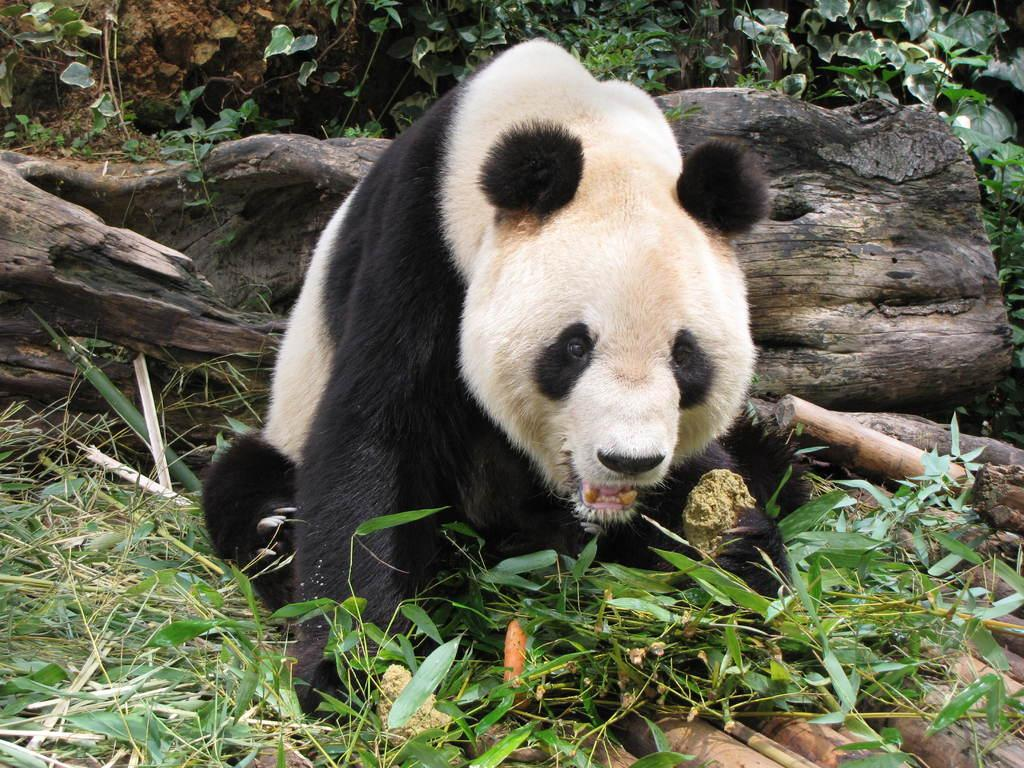What animal is featured in the picture? There is a panda in the picture. What can be seen on the trees in the picture? Tree bark is visible in the picture. What type of vegetation is in the background of the picture? There are plants in the background of the picture. What covers the ground in the picture? Grass is present on the ground in the picture. What type of soda is the panda drinking in the picture? There is no soda present in the picture; the panda is not shown drinking anything. 